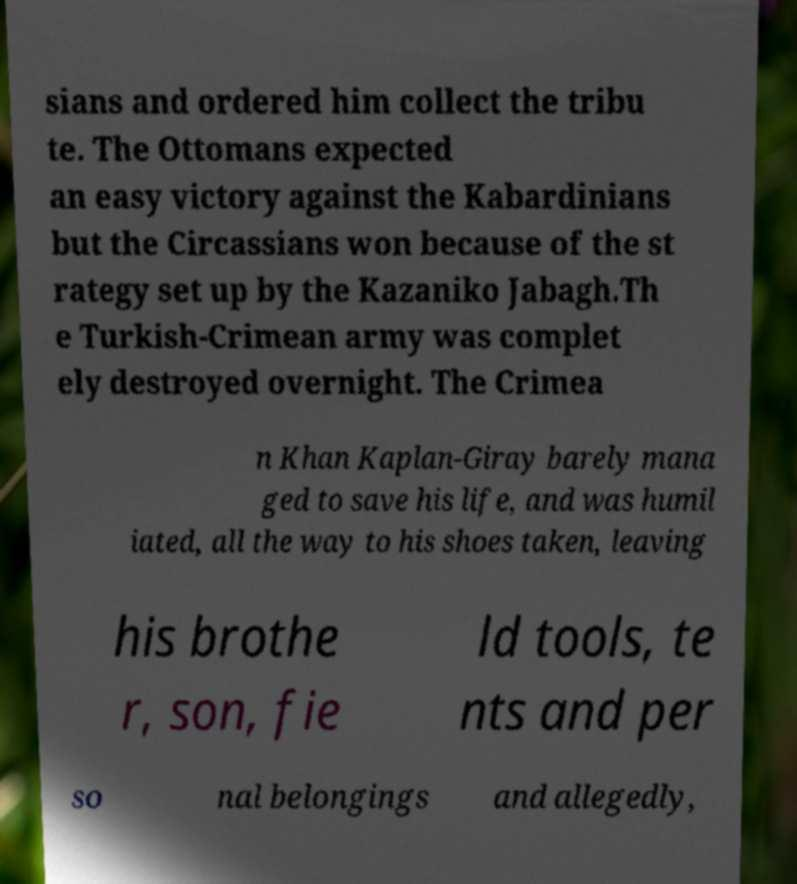There's text embedded in this image that I need extracted. Can you transcribe it verbatim? sians and ordered him collect the tribu te. The Ottomans expected an easy victory against the Kabardinians but the Circassians won because of the st rategy set up by the Kazaniko Jabagh.Th e Turkish-Crimean army was complet ely destroyed overnight. The Crimea n Khan Kaplan-Giray barely mana ged to save his life, and was humil iated, all the way to his shoes taken, leaving his brothe r, son, fie ld tools, te nts and per so nal belongings and allegedly, 